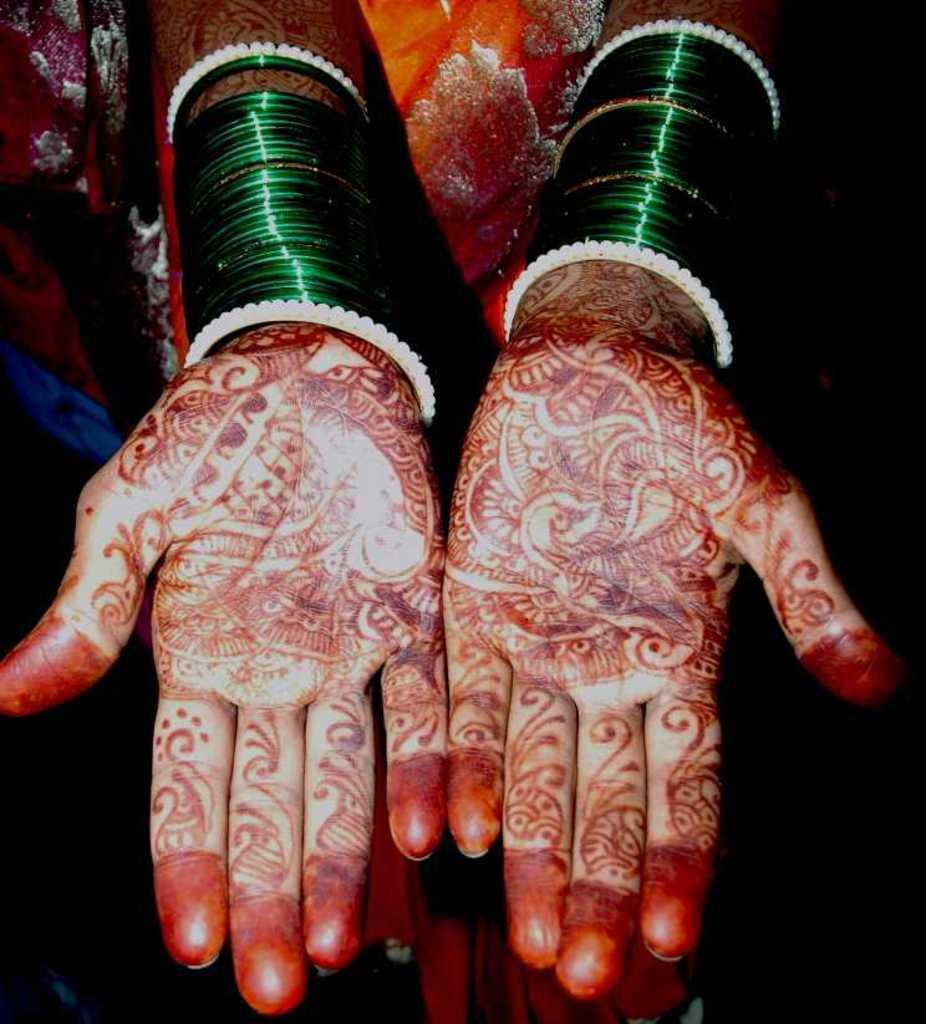What part of a person is visible in the image? The image contains the hands of a lady. What type of jewelry is the lady wearing on her hands? The lady is wearing bangles. What type of decorative design can be seen on the lady's hands? There are henna designs on the lady's hands. What type of ring can be seen on the lady's finger in the image? There is no ring visible on the lady's fingers in the image. 